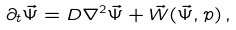<formula> <loc_0><loc_0><loc_500><loc_500>\partial _ { t } \vec { \Psi } = D \nabla ^ { 2 } \vec { \Psi } + \vec { W } ( \vec { \Psi } , p ) \, ,</formula> 